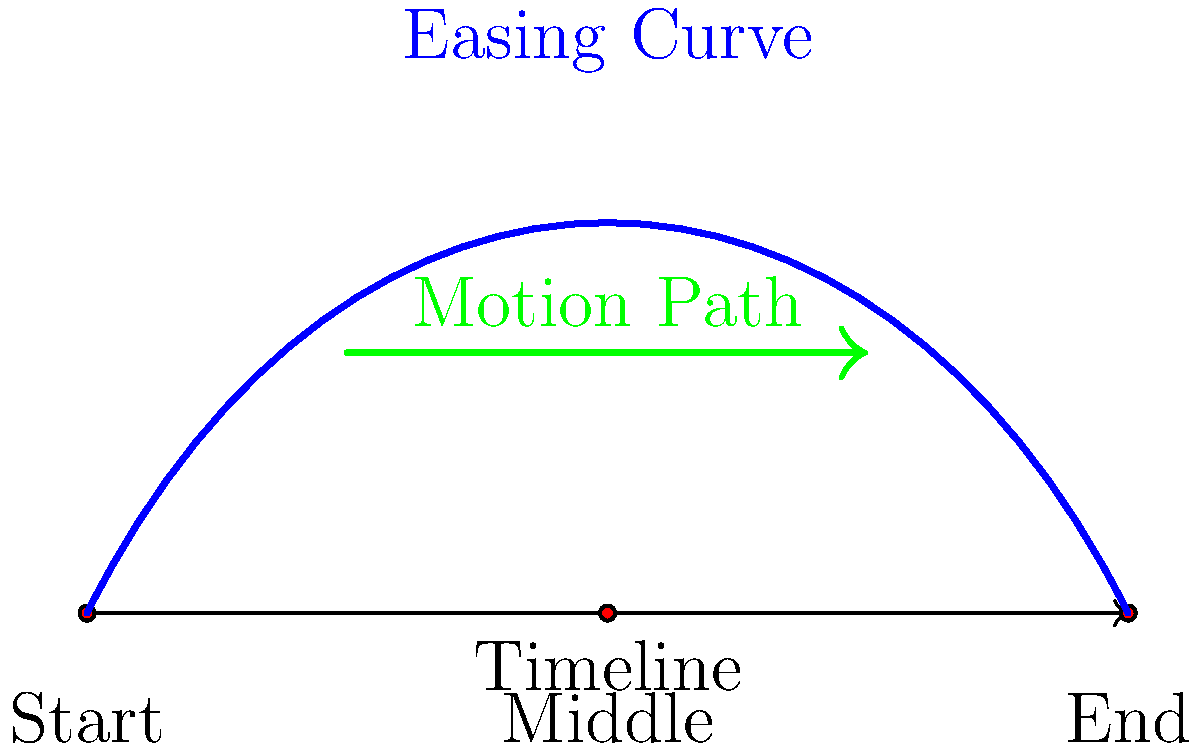In creating dynamic motion graphics for esports stream overlays, which easing function would be most appropriate for a smooth entrance animation of a team logo, considering the diagram above? To determine the most appropriate easing function for a smooth entrance animation of a team logo in esports stream overlays, we need to consider the following steps:

1. Analyze the diagram:
   - The timeline shows three keyframes: Start, Middle, and End.
   - There's a blue curve representing an easing function.
   - A green arrow indicates the motion path.

2. Understand easing functions:
   - Easing functions control the rate of change of an animation over time.
   - They can make animations feel more natural and less robotic.

3. Interpret the blue curve:
   - The curve starts slowly, accelerates in the middle, and then decelerates towards the end.
   - This pattern suggests a smooth, gradual entrance that picks up speed and then slows down.

4. Consider the context:
   - For a team logo entrance in esports overlays, we want a smooth, professional look.
   - The animation should grab attention without being too distracting.

5. Match the curve to known easing functions:
   - The shape of the curve closely resembles an "ease-in-out" function.
   - Ease-in-out starts slow, speeds up in the middle, and slows down at the end.

6. Evaluate the suitability:
   - An ease-in-out function would provide a smooth, natural-looking entrance for the logo.
   - It aligns with the professional aesthetics required for esports broadcasts.

Given these considerations, the most appropriate easing function for a smooth entrance animation of a team logo would be an ease-in-out function, as it matches the curve shown in the diagram and provides the desired smooth, professional look for esports stream overlays.
Answer: Ease-in-out function 